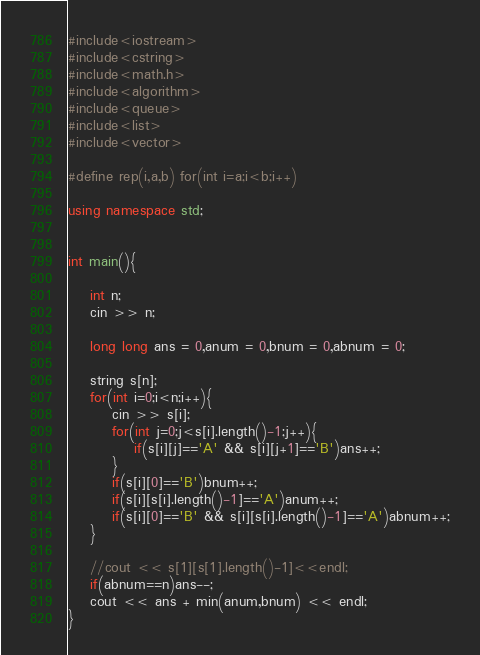Convert code to text. <code><loc_0><loc_0><loc_500><loc_500><_C++_>#include<iostream>
#include<cstring>
#include<math.h>
#include<algorithm>
#include<queue>
#include<list>
#include<vector>

#define rep(i,a,b) for(int i=a;i<b;i++)

using namespace std;


int main(){

    int n;
    cin >> n;

    long long ans = 0,anum = 0,bnum = 0,abnum = 0;

    string s[n];
    for(int i=0;i<n;i++){
        cin >> s[i];
        for(int j=0;j<s[i].length()-1;j++){
            if(s[i][j]=='A' && s[i][j+1]=='B')ans++;
        }
        if(s[i][0]=='B')bnum++;
        if(s[i][s[i].length()-1]=='A')anum++;
        if(s[i][0]=='B' && s[i][s[i].length()-1]=='A')abnum++;
    }

    //cout << s[1][s[1].length()-1]<<endl;
    if(abnum==n)ans--;
    cout << ans + min(anum,bnum) << endl;
}
</code> 